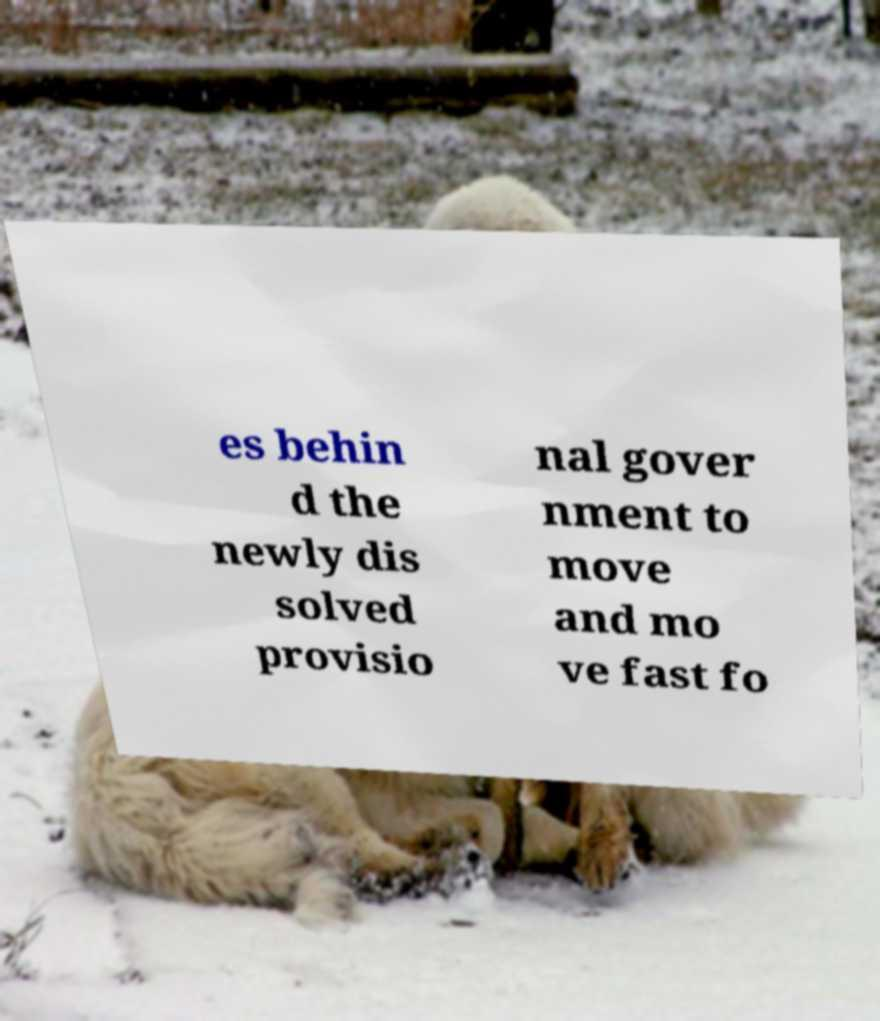Please read and relay the text visible in this image. What does it say? es behin d the newly dis solved provisio nal gover nment to move and mo ve fast fo 